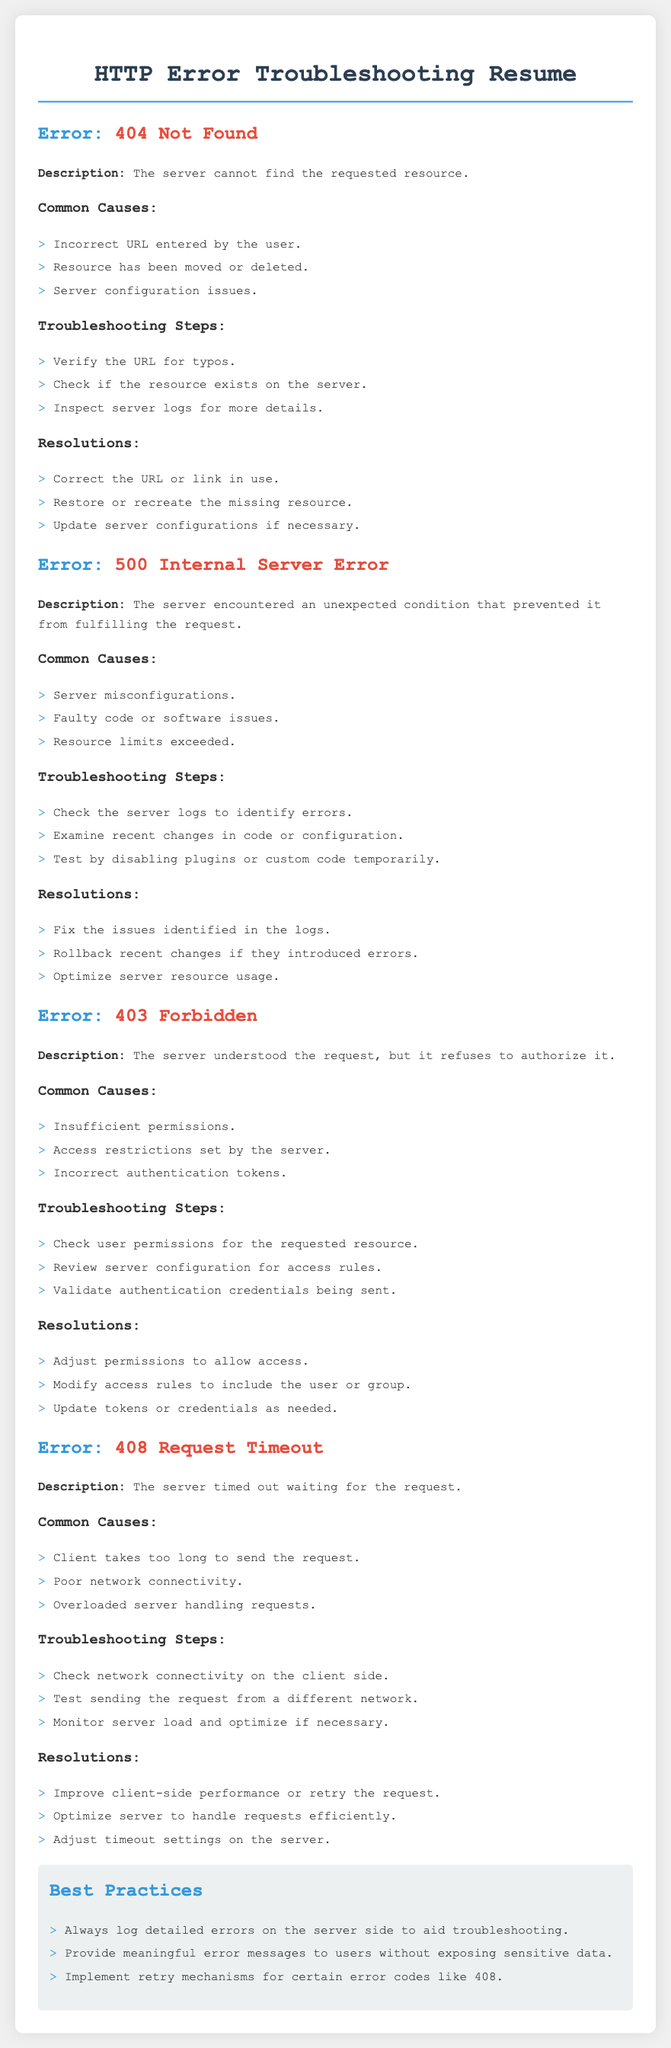What does the error code 404 signify? The error code 404 signifies that the server cannot find the requested resource.
Answer: Not Found What is one common cause of a 500 Internal Server Error? One common cause of a 500 Internal Server Error is server misconfigurations.
Answer: Server misconfigurations What troubleshooting step should be taken for a 403 Forbidden error? A troubleshooting step for a 403 Forbidden error is to check user permissions for the requested resource.
Answer: Check user permissions What is the description of the 408 Request Timeout error? The description of the 408 Request Timeout error is that the server timed out waiting for the request.
Answer: Timed out waiting for the request Name one resolution for a 404 error. One resolution for a 404 error is to correct the URL or link in use.
Answer: Correct the URL What does the best practice recommend regarding error logs? The best practice recommends logging detailed errors on the server side to aid troubleshooting.
Answer: Log detailed errors How should access restrictions be managed for a 403 error? Access restrictions should be modified to include the user or group for a 403 error.
Answer: Modify access rules What is stated as a common cause for the 408 error? A common cause for the 408 error is poor network connectivity.
Answer: Poor network connectivity What is the suggested action if a resource limit is exceeded? The suggested action if a resource limit is exceeded is to optimize server resource usage.
Answer: Optimize server resource usage 